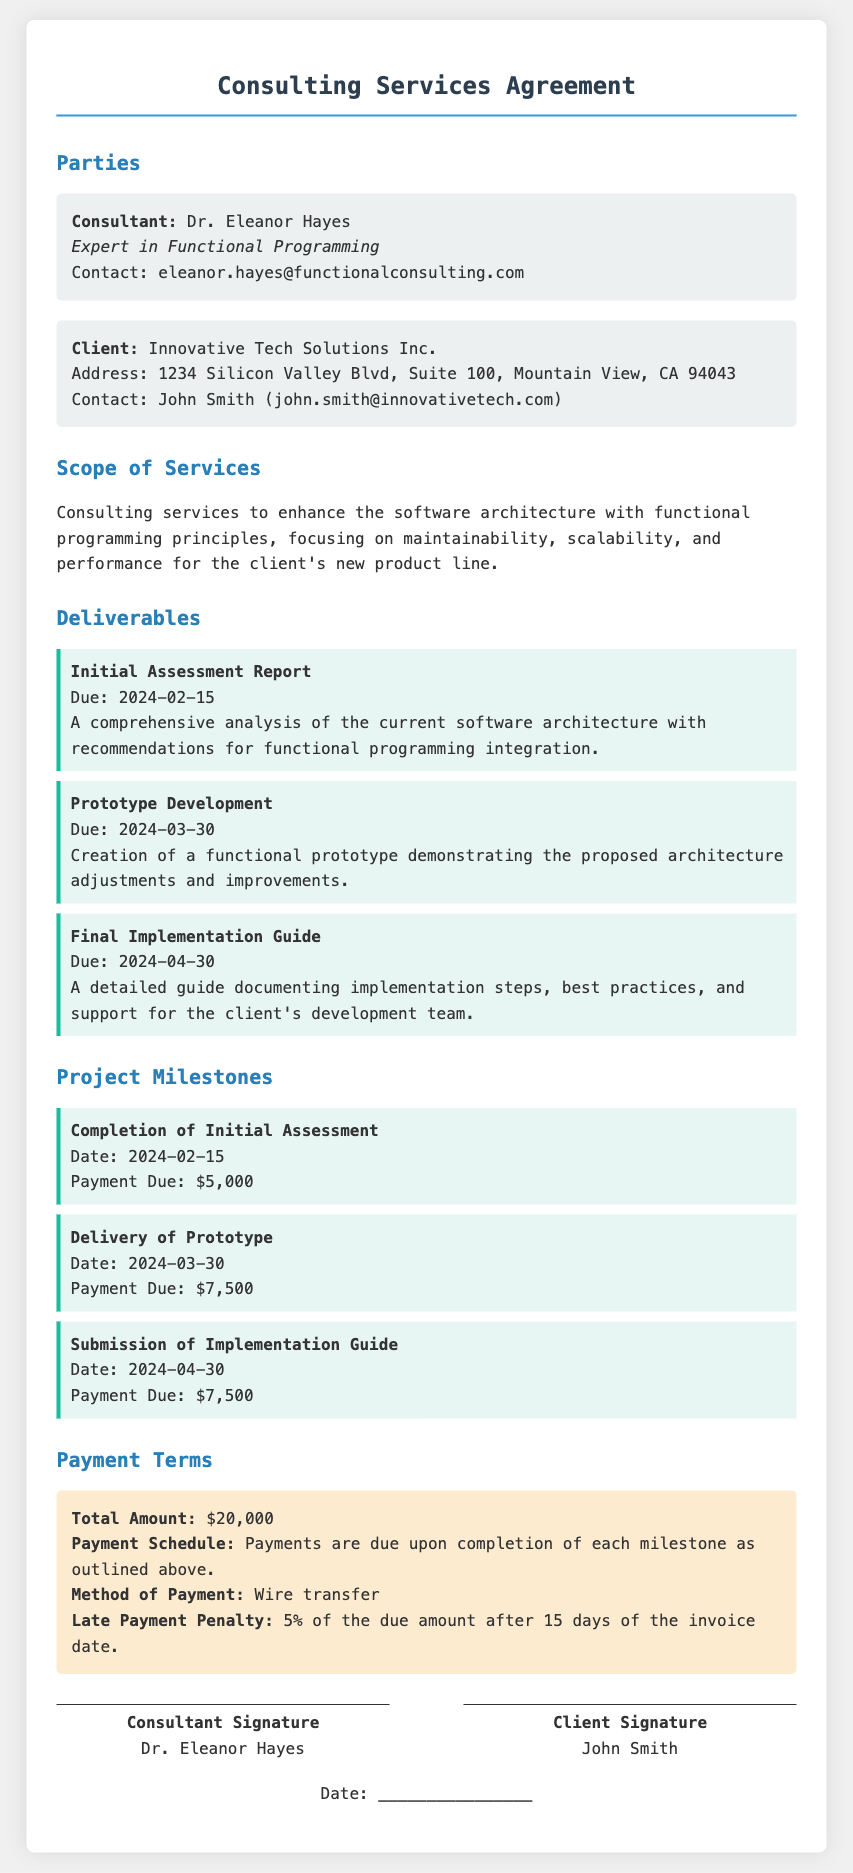what is the name of the consultant? The consultant's name is clearly stated in the document as Dr. Eleanor Hayes.
Answer: Dr. Eleanor Hayes what is the due date for the Initial Assessment Report? The due date for the Initial Assessment Report is explicitly mentioned in the document as 2024-02-15.
Answer: 2024-02-15 how much is the payment due upon delivery of the Prototype? The amount due upon delivery of the Prototype is clearly noted in the milestones section as $7,500.
Answer: $7,500 what is the total amount of the contract? The total amount of the contract is specified in the payment terms of the document, amounting to $20,000.
Answer: $20,000 who is the client contact person? The document identifies the client contact person as John Smith, along with his email address.
Answer: John Smith what is the late payment penalty percentage? The document states that the late payment penalty is 5% of the due amount after 15 days of the invoice date.
Answer: 5% which deliverable is due on 2024-03-30? The document outlines that the deliverable due on 2024-03-30 is the Prototype Development.
Answer: Prototype Development what method of payment is specified in the document? The document mentions that the method of payment is wire transfer.
Answer: wire transfer what are the three main milestones in the project? The key project milestones include completion of Initial Assessment, delivery of Prototype, and submission of Implementation Guide.
Answer: Initial Assessment, Prototype, Implementation Guide 